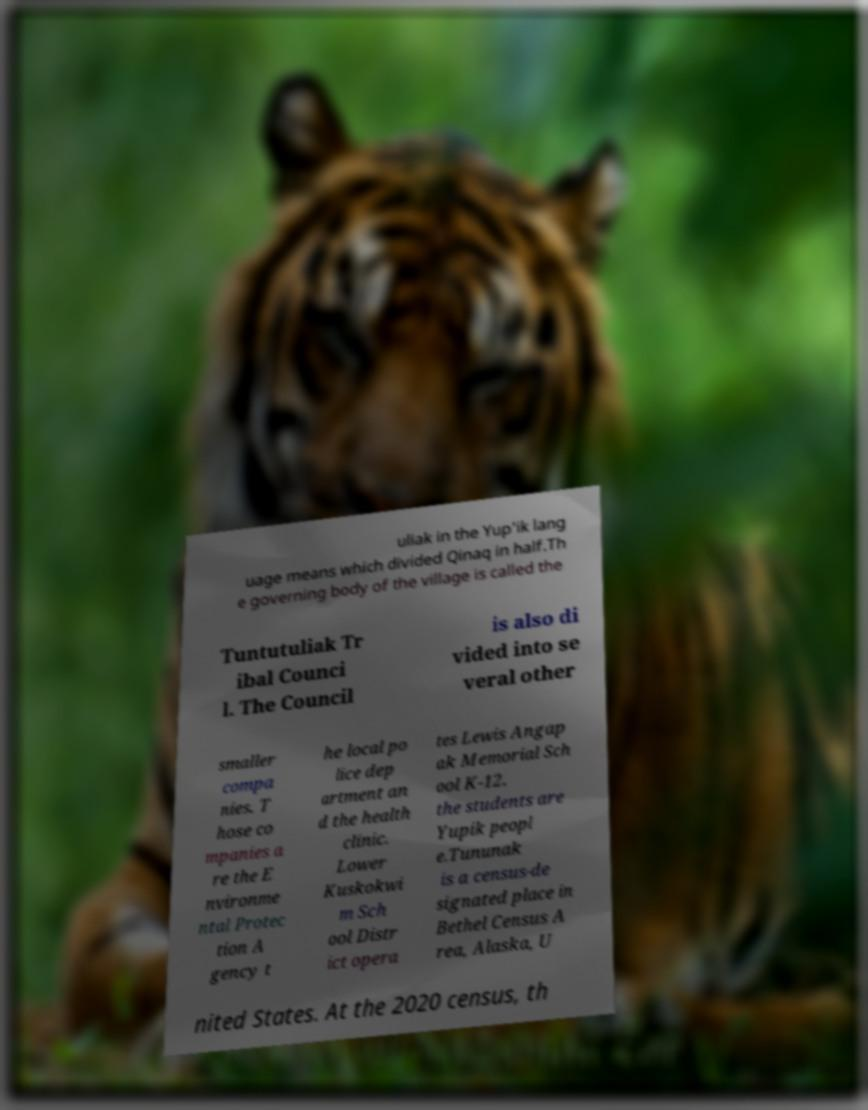Can you accurately transcribe the text from the provided image for me? uliak in the Yup'ik lang uage means which divided Qinaq in half.Th e governing body of the village is called the Tuntutuliak Tr ibal Counci l. The Council is also di vided into se veral other smaller compa nies. T hose co mpanies a re the E nvironme ntal Protec tion A gency t he local po lice dep artment an d the health clinic. Lower Kuskokwi m Sch ool Distr ict opera tes Lewis Angap ak Memorial Sch ool K-12. the students are Yupik peopl e.Tununak is a census-de signated place in Bethel Census A rea, Alaska, U nited States. At the 2020 census, th 